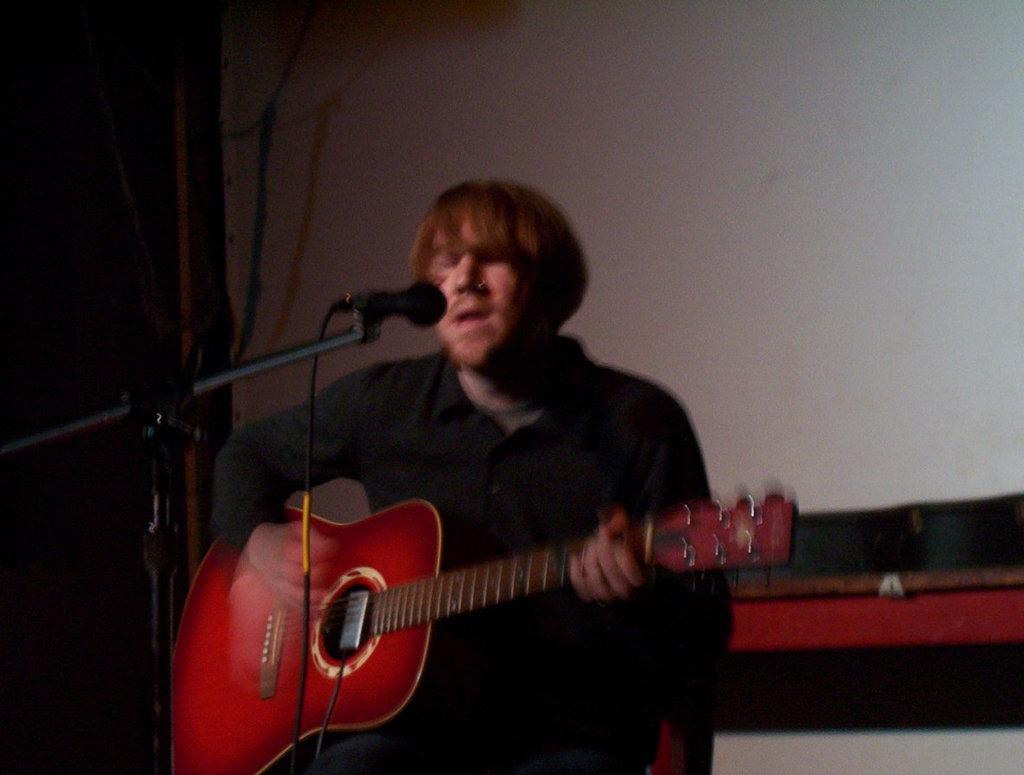What is the man in the image doing? The man is standing, singing a song, and playing a guitar. What object is the man using to amplify his voice? There is a microphone with a microphone stand in the image. What can be seen in the background of the image? There is a white wall in the image. What type of potato is the governor eating in the image? There is no governor or potato present in the image. What is the rate of the man's singing in the image? The provided facts do not mention the speed or rate of the man's singing, so it cannot be determined from the image. 